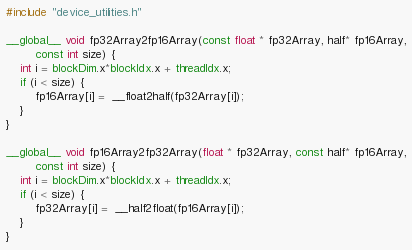Convert code to text. <code><loc_0><loc_0><loc_500><loc_500><_Cuda_>#include "device_utilities.h"

__global__ void fp32Array2fp16Array(const float * fp32Array, half* fp16Array,
		const int size) {
	int i = blockDim.x*blockIdx.x + threadIdx.x;
	if (i < size) {
		fp16Array[i] =  __float2half(fp32Array[i]);
	}
}

__global__ void fp16Array2fp32Array(float * fp32Array, const half* fp16Array,
		const int size) {
	int i = blockDim.x*blockIdx.x + threadIdx.x;
	if (i < size) {
		fp32Array[i] =  __half2float(fp16Array[i]);
	}
}</code> 